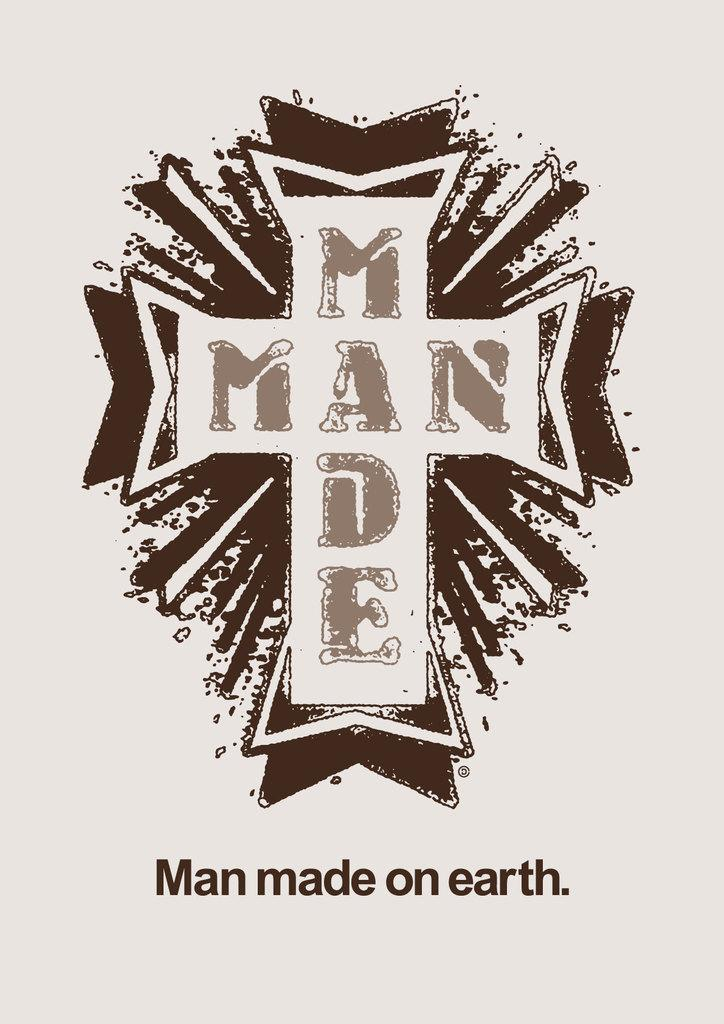<image>
Present a compact description of the photo's key features. a cross with the words Man made on earth at the bottom 